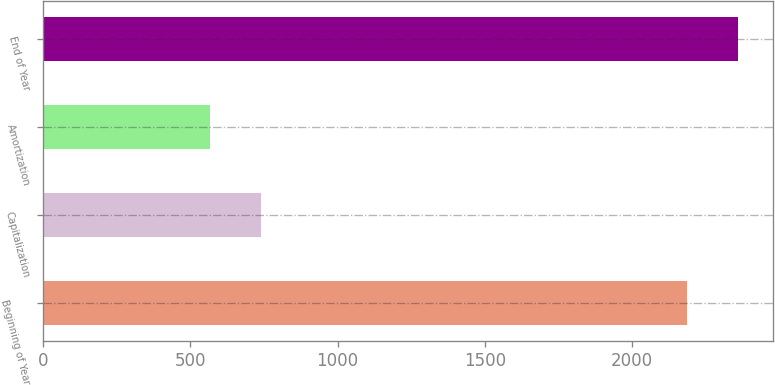<chart> <loc_0><loc_0><loc_500><loc_500><bar_chart><fcel>Beginning of Year<fcel>Capitalization<fcel>Amortization<fcel>End of Year<nl><fcel>2184.6<fcel>739.89<fcel>565.5<fcel>2358.99<nl></chart> 